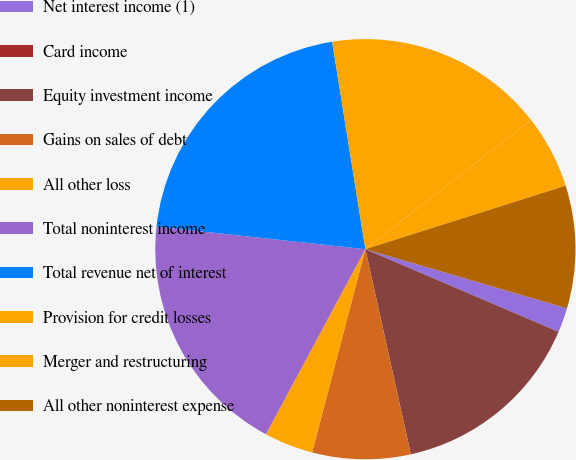<chart> <loc_0><loc_0><loc_500><loc_500><pie_chart><fcel>Net interest income (1)<fcel>Card income<fcel>Equity investment income<fcel>Gains on sales of debt<fcel>All other loss<fcel>Total noninterest income<fcel>Total revenue net of interest<fcel>Provision for credit losses<fcel>Merger and restructuring<fcel>All other noninterest expense<nl><fcel>1.89%<fcel>0.0%<fcel>15.09%<fcel>7.55%<fcel>3.77%<fcel>18.87%<fcel>20.75%<fcel>16.98%<fcel>5.66%<fcel>9.43%<nl></chart> 